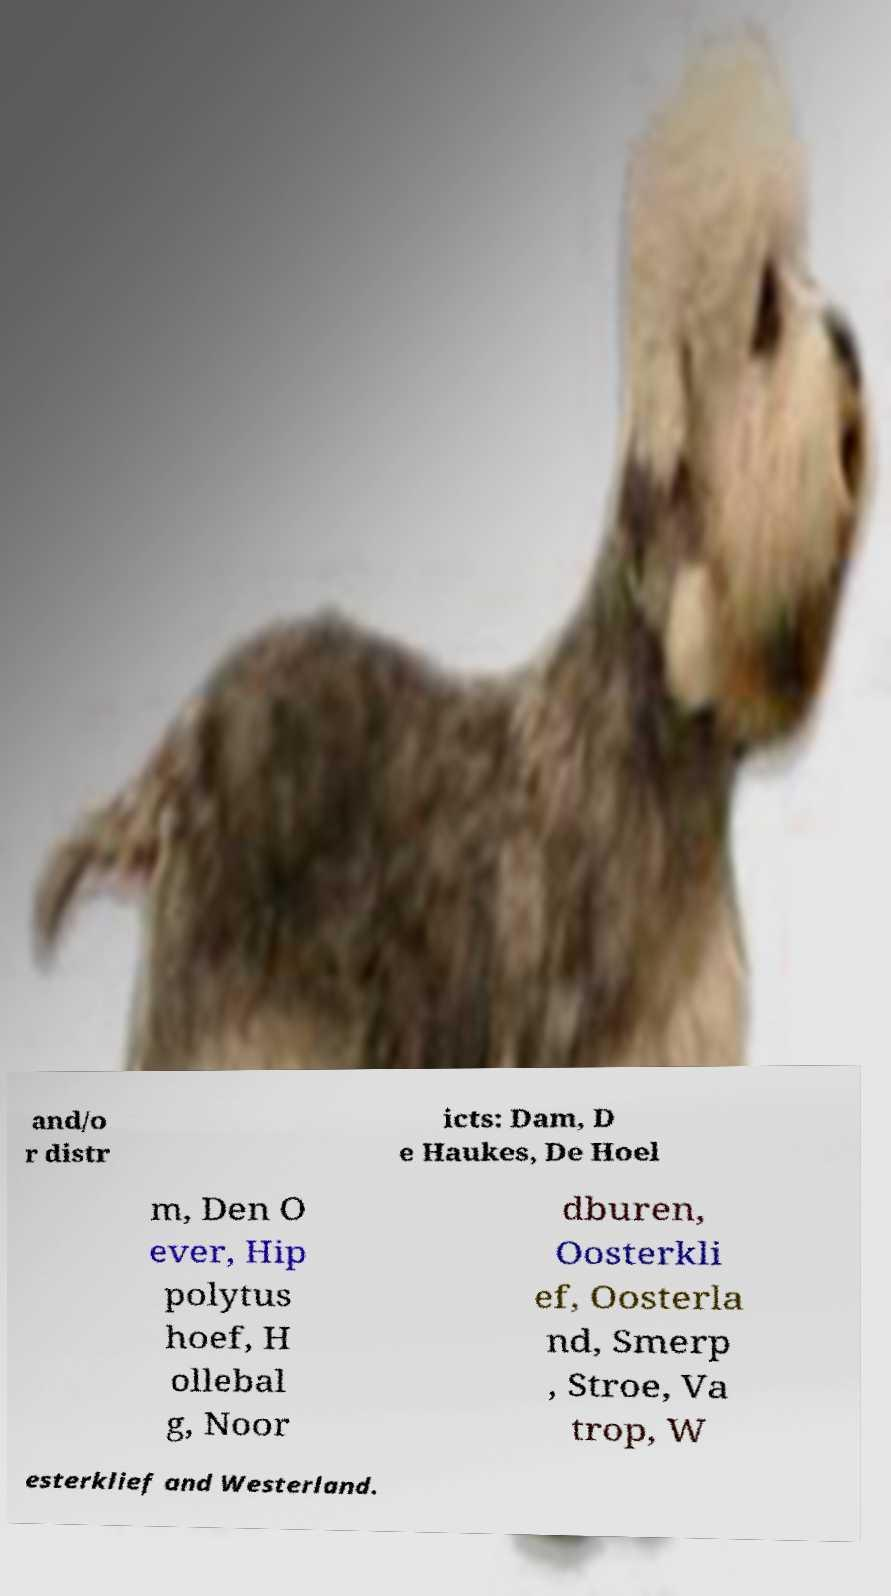There's text embedded in this image that I need extracted. Can you transcribe it verbatim? and/o r distr icts: Dam, D e Haukes, De Hoel m, Den O ever, Hip polytus hoef, H ollebal g, Noor dburen, Oosterkli ef, Oosterla nd, Smerp , Stroe, Va trop, W esterklief and Westerland. 